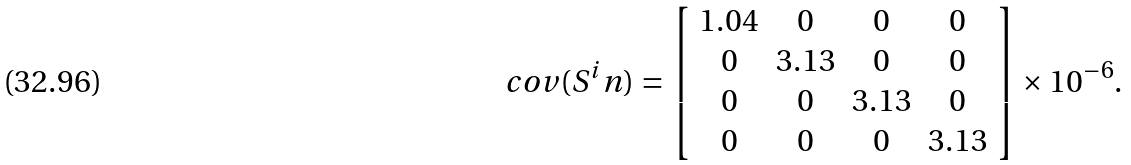<formula> <loc_0><loc_0><loc_500><loc_500>c o v ( S ^ { i } n ) = \left [ \begin{array} { c c c c } 1 . 0 4 & 0 & 0 & 0 \\ 0 & 3 . 1 3 & 0 & 0 \\ 0 & 0 & 3 . 1 3 & 0 \\ 0 & 0 & 0 & 3 . 1 3 \end{array} \right ] \times 1 0 ^ { - 6 } .</formula> 